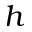Convert formula to latex. <formula><loc_0><loc_0><loc_500><loc_500>h</formula> 